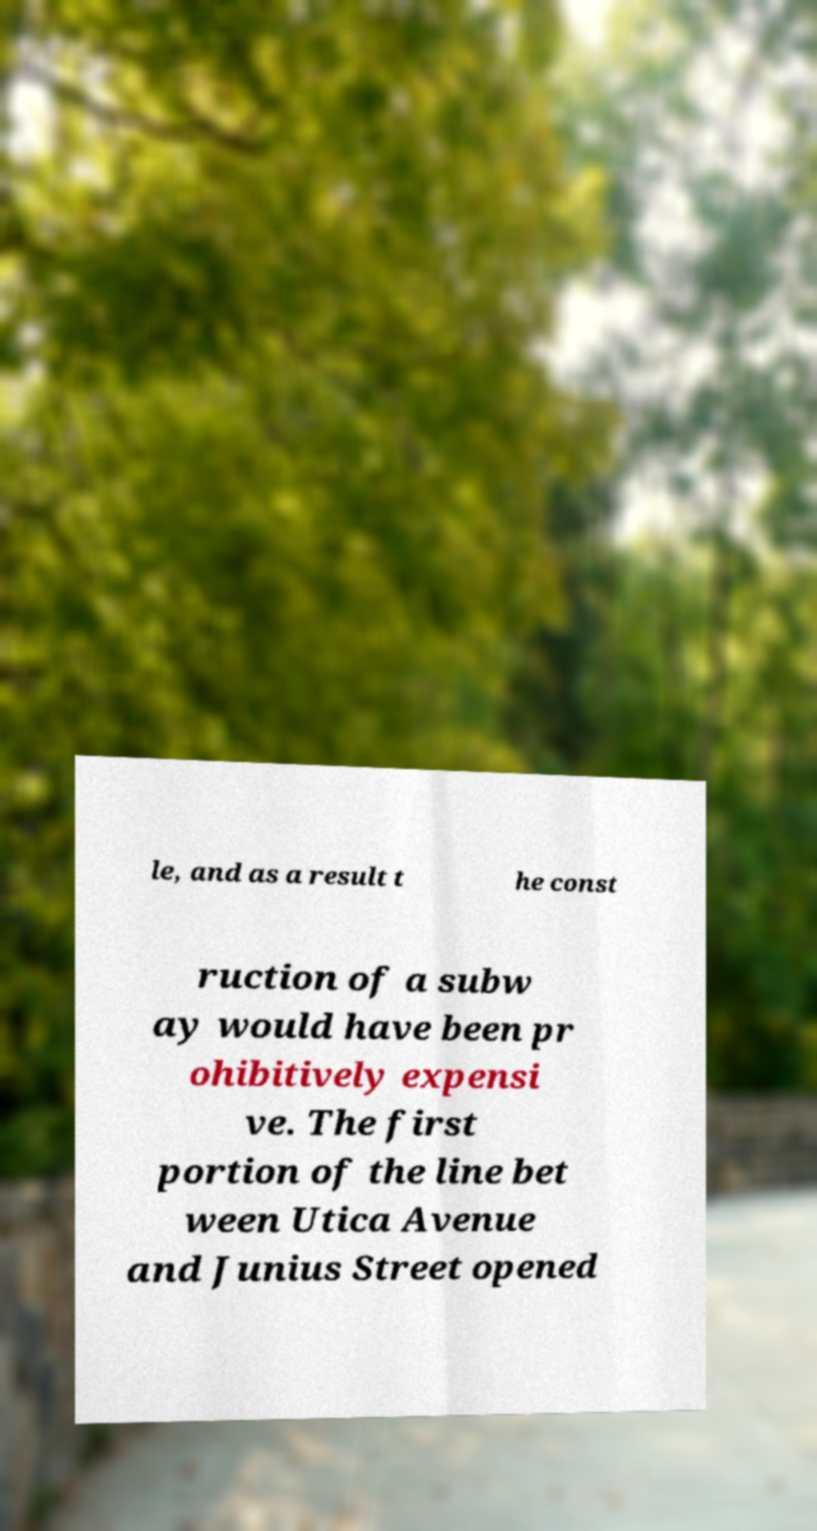Can you read and provide the text displayed in the image?This photo seems to have some interesting text. Can you extract and type it out for me? le, and as a result t he const ruction of a subw ay would have been pr ohibitively expensi ve. The first portion of the line bet ween Utica Avenue and Junius Street opened 